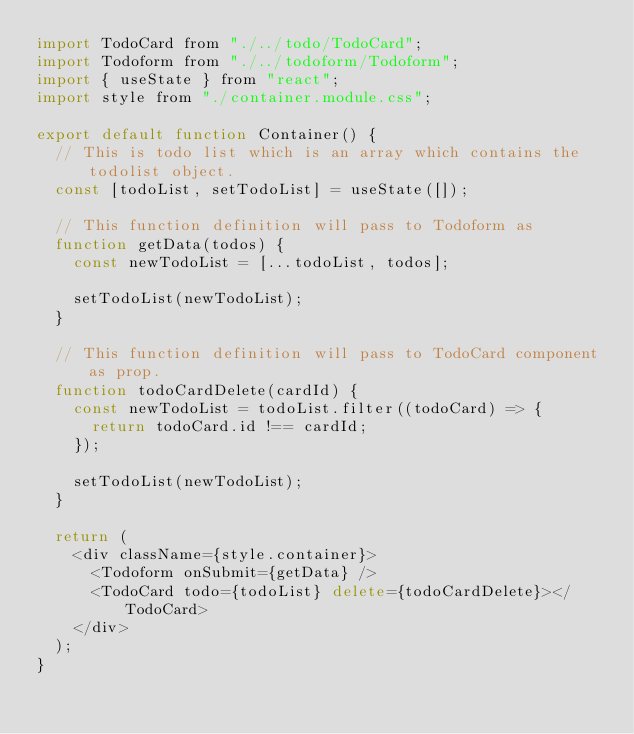Convert code to text. <code><loc_0><loc_0><loc_500><loc_500><_JavaScript_>import TodoCard from "./../todo/TodoCard";
import Todoform from "./../todoform/Todoform";
import { useState } from "react";
import style from "./container.module.css";

export default function Container() {
  // This is todo list which is an array which contains the todolist object.
  const [todoList, setTodoList] = useState([]);

  // This function definition will pass to Todoform as
  function getData(todos) {
    const newTodoList = [...todoList, todos];

    setTodoList(newTodoList);
  }

  // This function definition will pass to TodoCard component as prop.
  function todoCardDelete(cardId) {
    const newTodoList = todoList.filter((todoCard) => {
      return todoCard.id !== cardId;
    });

    setTodoList(newTodoList);
  }

  return (
    <div className={style.container}>
      <Todoform onSubmit={getData} />
      <TodoCard todo={todoList} delete={todoCardDelete}></TodoCard>
    </div>
  );
}
</code> 